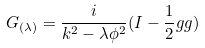Convert formula to latex. <formula><loc_0><loc_0><loc_500><loc_500>G _ { ( \lambda ) } = \frac { i } { k ^ { 2 } - \lambda \phi ^ { 2 } } ( I - \frac { 1 } { 2 } g g )</formula> 